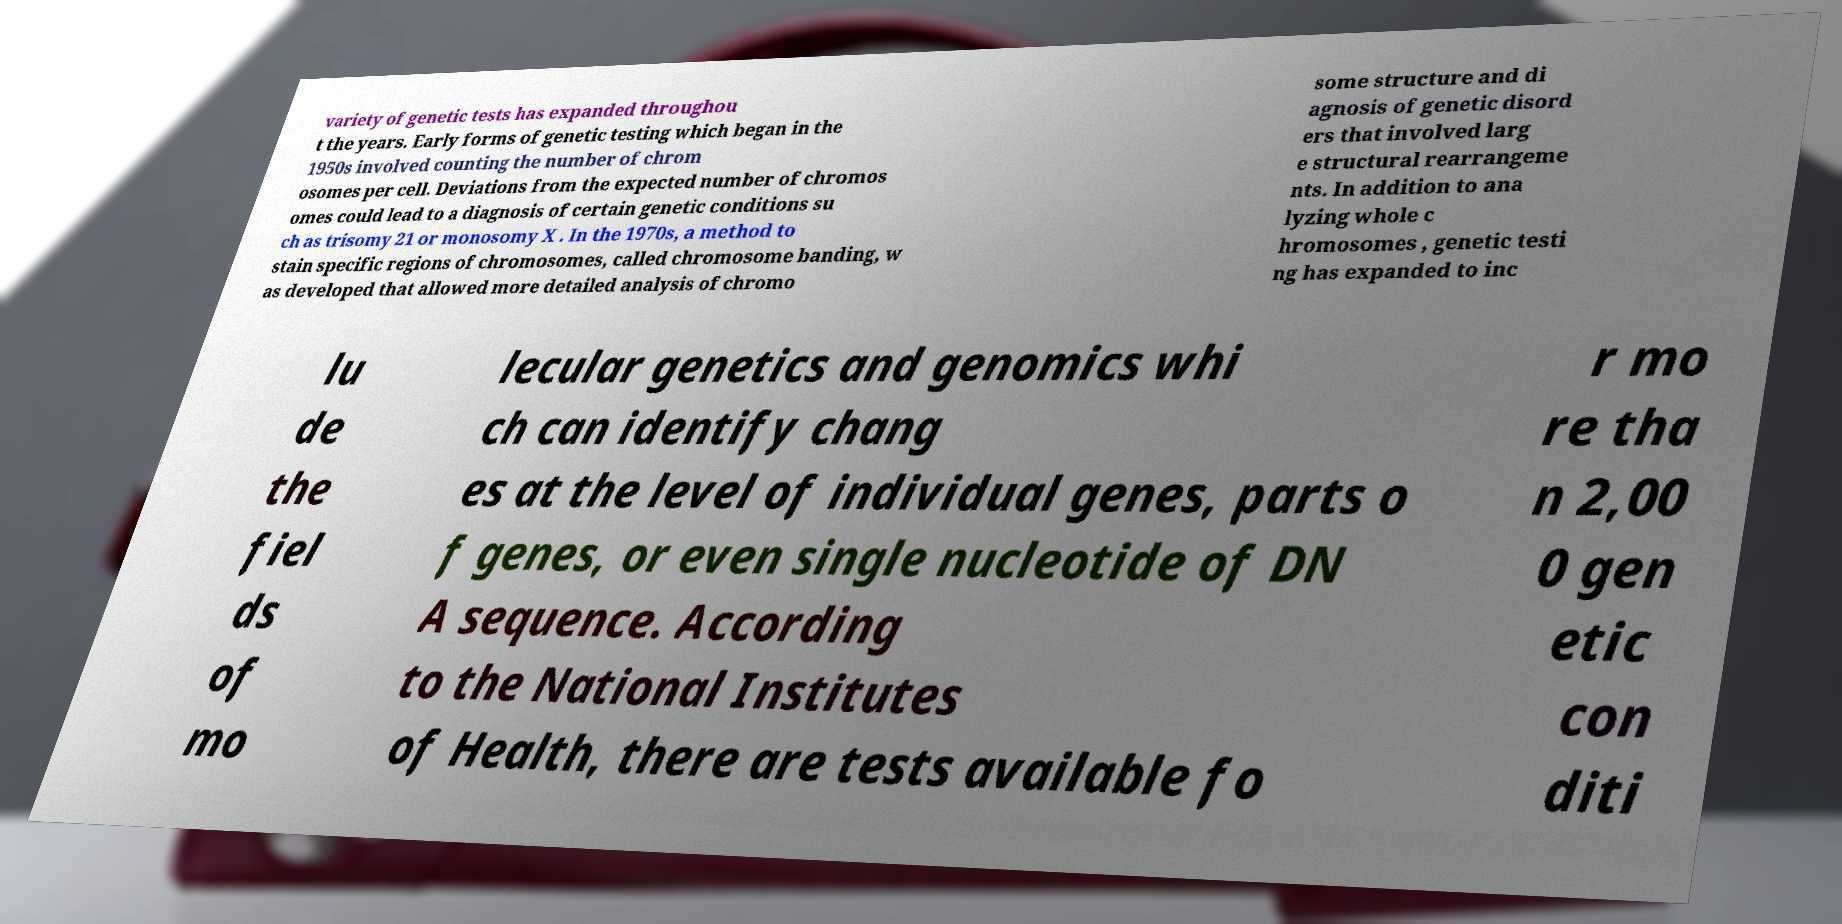What messages or text are displayed in this image? I need them in a readable, typed format. variety of genetic tests has expanded throughou t the years. Early forms of genetic testing which began in the 1950s involved counting the number of chrom osomes per cell. Deviations from the expected number of chromos omes could lead to a diagnosis of certain genetic conditions su ch as trisomy 21 or monosomy X . In the 1970s, a method to stain specific regions of chromosomes, called chromosome banding, w as developed that allowed more detailed analysis of chromo some structure and di agnosis of genetic disord ers that involved larg e structural rearrangeme nts. In addition to ana lyzing whole c hromosomes , genetic testi ng has expanded to inc lu de the fiel ds of mo lecular genetics and genomics whi ch can identify chang es at the level of individual genes, parts o f genes, or even single nucleotide of DN A sequence. According to the National Institutes of Health, there are tests available fo r mo re tha n 2,00 0 gen etic con diti 